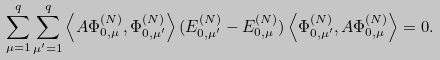Convert formula to latex. <formula><loc_0><loc_0><loc_500><loc_500>\sum _ { \mu = 1 } ^ { q } \sum _ { \mu ^ { \prime } = 1 } ^ { q } \left \langle A \Phi _ { 0 , \mu } ^ { ( N ) } , \Phi _ { 0 , \mu ^ { \prime } } ^ { ( N ) } \right \rangle ( E _ { 0 , \mu ^ { \prime } } ^ { ( N ) } - E _ { 0 , \mu } ^ { ( N ) } ) \left \langle \Phi _ { 0 , \mu ^ { \prime } } ^ { ( N ) } , A \Phi _ { 0 , \mu } ^ { ( N ) } \right \rangle = 0 .</formula> 